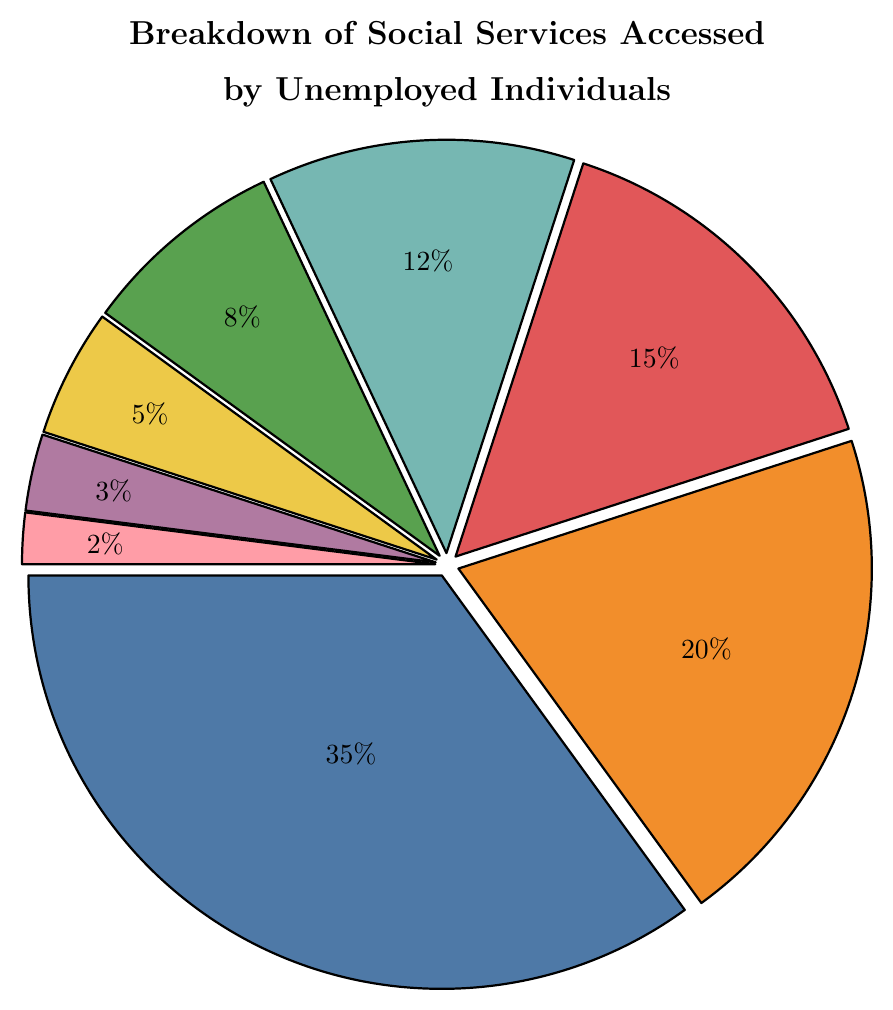What's the largest category of social services accessed by unemployed individuals? The figure shows a pie chart with different categories of social services and their percentages. Unemployment Benefits slice is the largest one at 35%.
Answer: Unemployment Benefits What percentage of unemployed individuals access Healthcare Subsidies? The chart includes a slice labeled as Healthcare Subsidies which lists the value. According to the chart, it’s 15%.
Answer: 15% Which is accessed more: Food Assistance or Job Training Programs? By examining the chart, the Food Assistance slice is 20% and Job Training Programs slice is 12%. Since 20% is larger than 12%, Food Assistance is accessed more.
Answer: Food Assistance Which two categories have the smallest percentages? The two smallest slices in the chart belong to Mental Health Services and Transportation Assistance with 2% and 3%, respectively.
Answer: Mental Health Services and Transportation Assistance What is the total percentage of services accessed that fall under Housing Assistance and Childcare Support? According to the chart, the percentage for Housing Assistance is 8% and for Childcare Support is 5%. Adding these together: 8% + 5% = 13%.
Answer: 13% Are Unemployment Benefits and Food Assistance combined more than 50%? The figure shows Unemployment Benefits at 35% and Food Assistance at 20%. Sum them up: 35% + 20% = 55%. This is more than 50%.
Answer: Yes What color represents Healthcare Subsidies on the pie chart? By looking at the chart, Healthcare Subsidies is represented by a specific color slice. It is the color corresponding to Healthcare Subsidies (red).
Answer: Red Which service type has a higher percentage, Housing Assistance or Job Training Programs? Referring to the pie chart, Job Training Programs is 12% while Housing Assistance is 8%. Since 12% is greater than 8%, Job Training Programs has a higher percentage.
Answer: Job Training Programs How does the percentage of Food Assistance compare to the sum of Childcare Support and Transportation Assistance? Food Assistance is 20%. Childcare Support is 5% and Transportation Assistance is 3%. Sum of Childcare Support and Transportation Assistance: 5% + 3% = 8%. Since 20% is greater than 8%, Food Assistance is higher.
Answer: Food Assistance is higher What service has a percentage closest to 10%? Observing the chart, the Job Training Programs slice is at 12%, which is closest to 10%.
Answer: Job Training Programs 